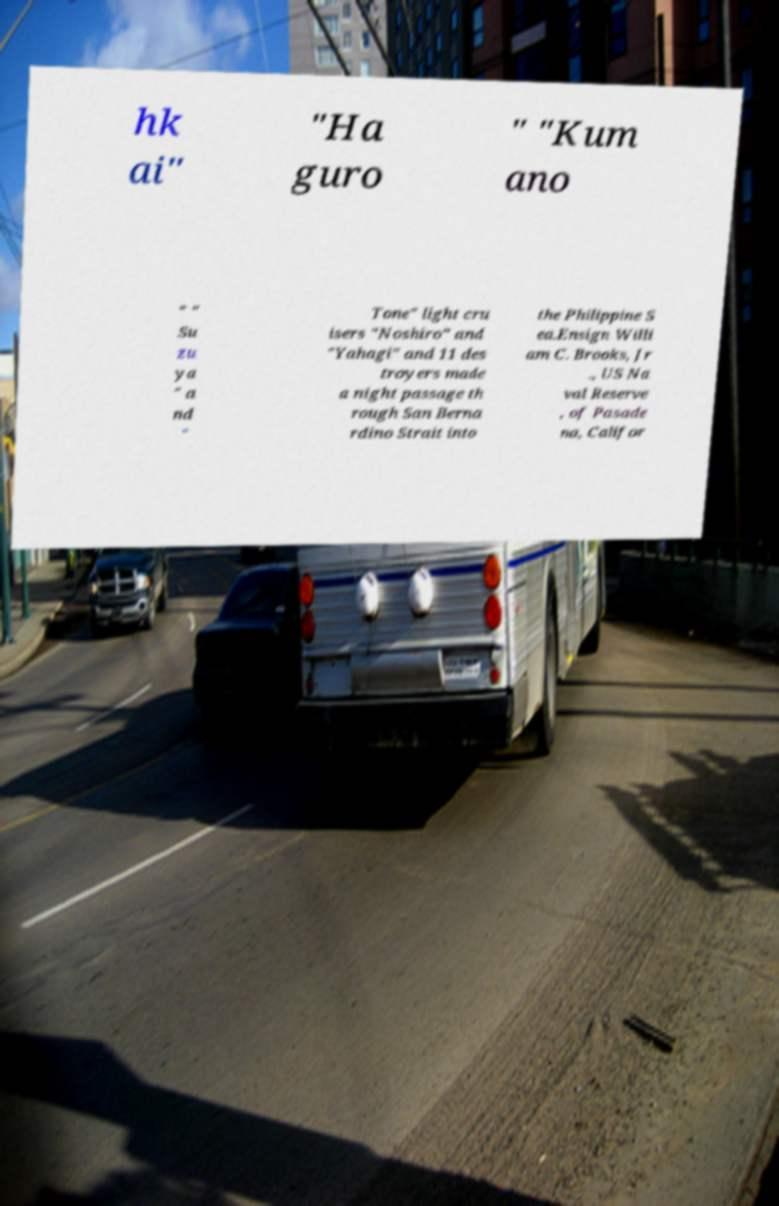Can you accurately transcribe the text from the provided image for me? hk ai" "Ha guro " "Kum ano " " Su zu ya " a nd " Tone" light cru isers "Noshiro" and "Yahagi" and 11 des troyers made a night passage th rough San Berna rdino Strait into the Philippine S ea.Ensign Willi am C. Brooks, Jr ., US Na val Reserve , of Pasade na, Califor 